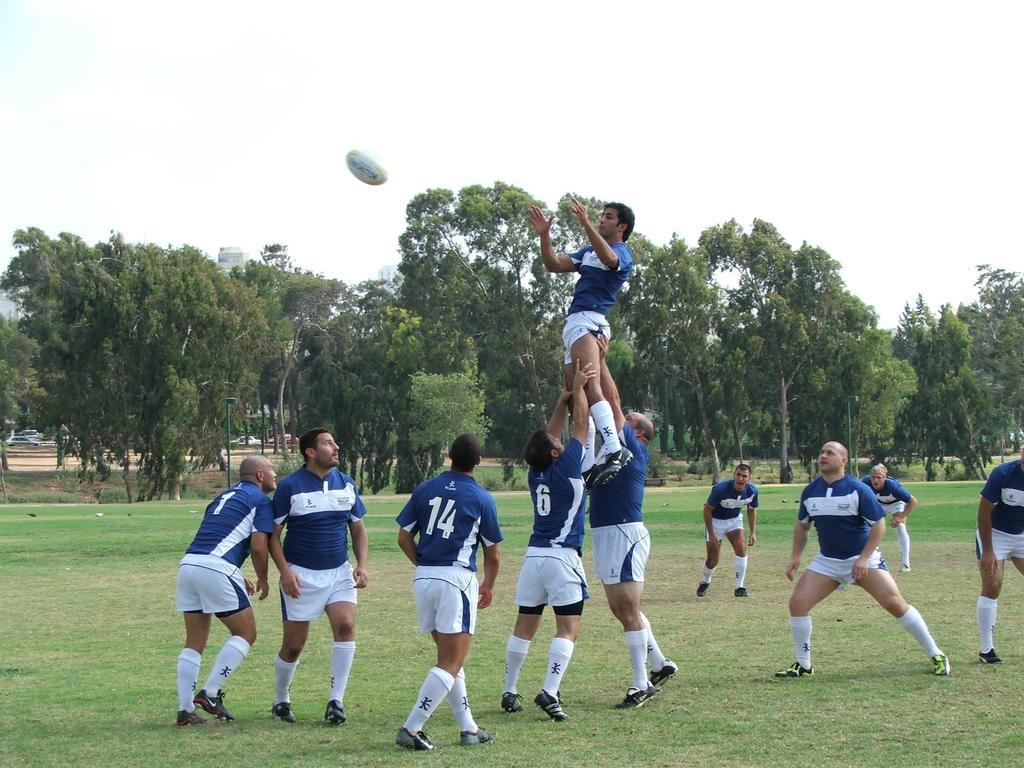<image>
Provide a brief description of the given image. people playing sports in a park field wearing numbered jerseys like 14 